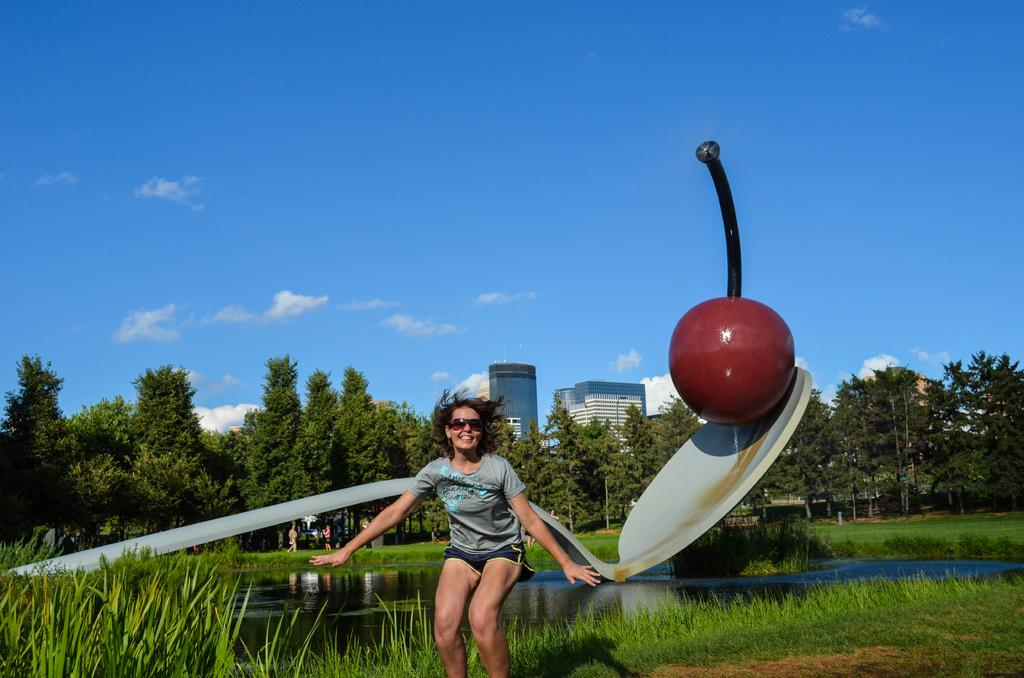What is the person in the image doing? The person in the image is standing and smiling. What type of natural environment is visible in the image? There is grass, water, and trees in the image. What man-made structure can be seen in the image? There are buildings in the image. What is the weather like in the image? The sky is visible in the background of the image, suggesting that it is a clear day. What unique object is present in the image? There is a statue of a cherry on a spoon in the image. What meal is the person eating in the image? There is no meal present in the image; the person is simply standing and smiling. What rule is being enforced by the statue of a cherry on a spoon in the image? The statue of a cherry on a spoon is not enforcing any rule; it is a decorative object in the image. 